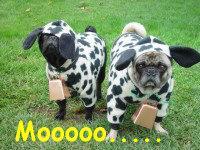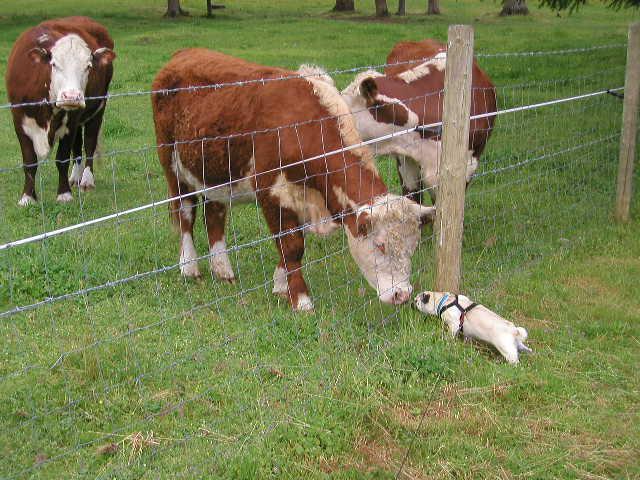The first image is the image on the left, the second image is the image on the right. Analyze the images presented: Is the assertion "Images show a total of two pugs dressed in black and white cow costumes." valid? Answer yes or no. Yes. 